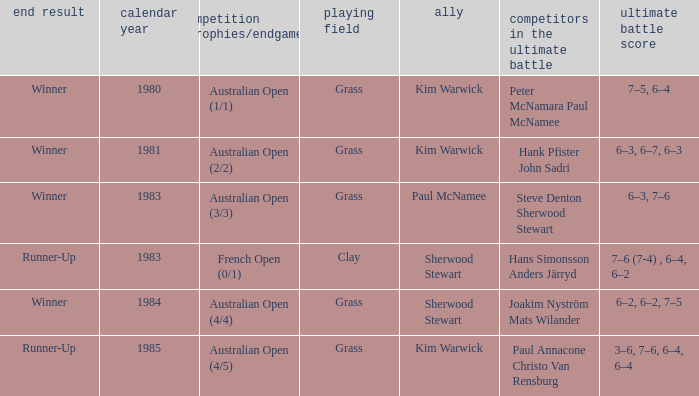How many different outcomes did the final with Paul McNamee as a partner have? 1.0. 